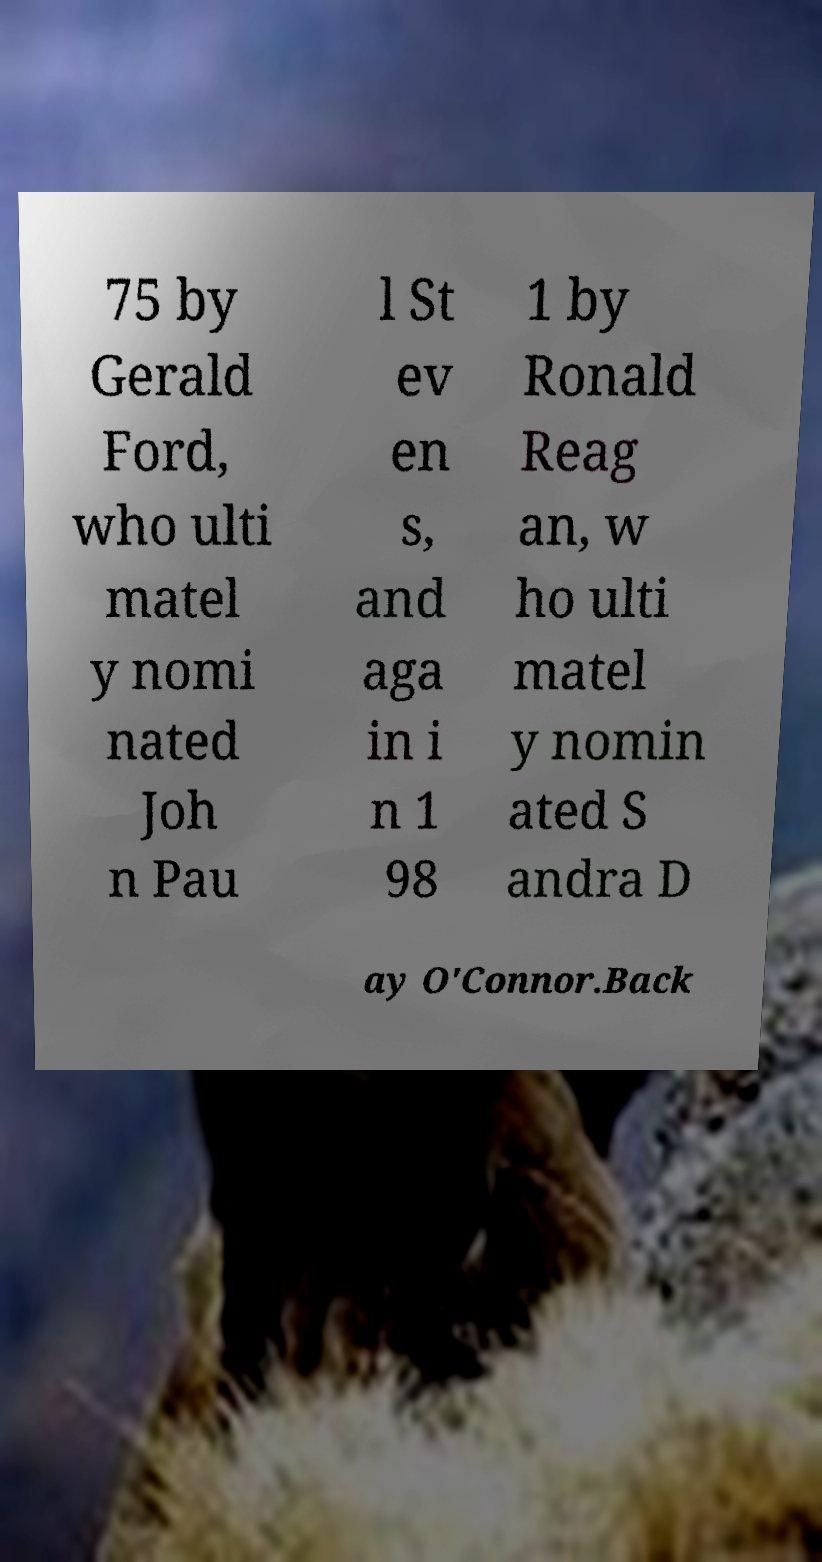There's text embedded in this image that I need extracted. Can you transcribe it verbatim? 75 by Gerald Ford, who ulti matel y nomi nated Joh n Pau l St ev en s, and aga in i n 1 98 1 by Ronald Reag an, w ho ulti matel y nomin ated S andra D ay O'Connor.Back 